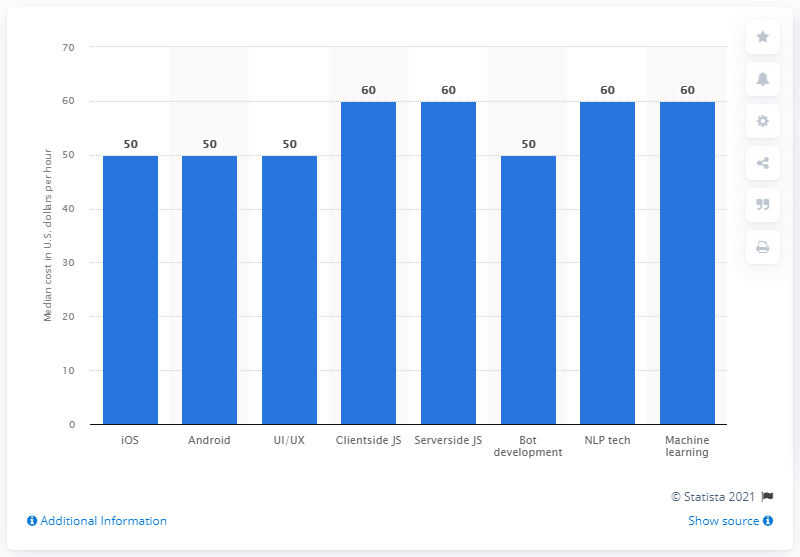Indicate a few pertinent items in this graphic. The median cost per hour for iOS app development was approximately $50. 